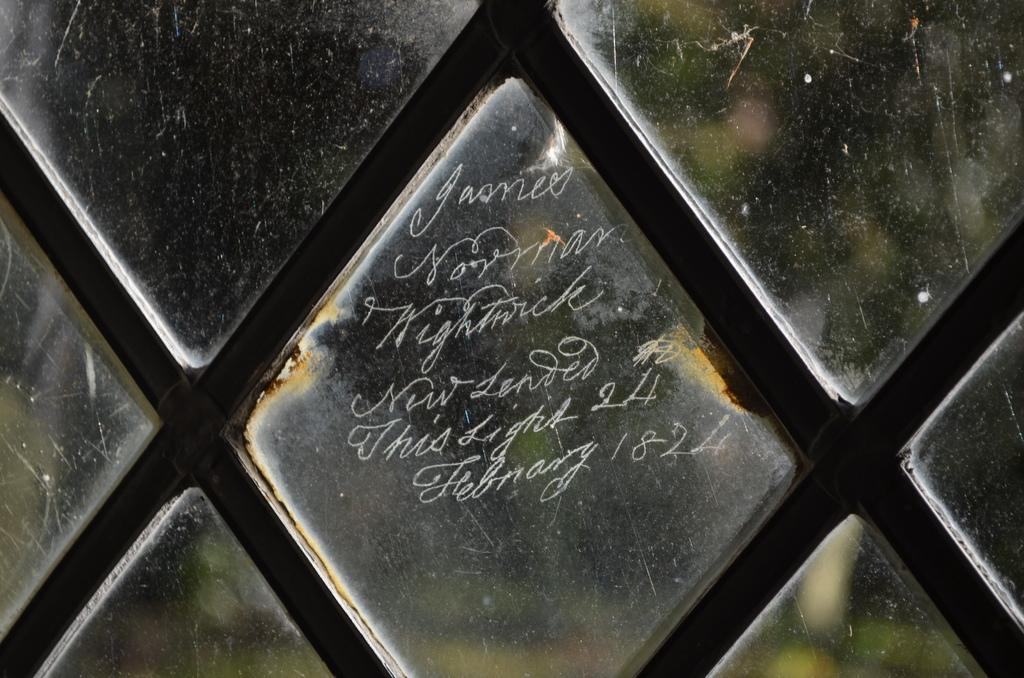What is present on the glass window in the image? There is text on a glass window in the image. What type of pain is the person in the image experiencing? There is no person present in the image, and therefore no indication of any pain being experienced. 